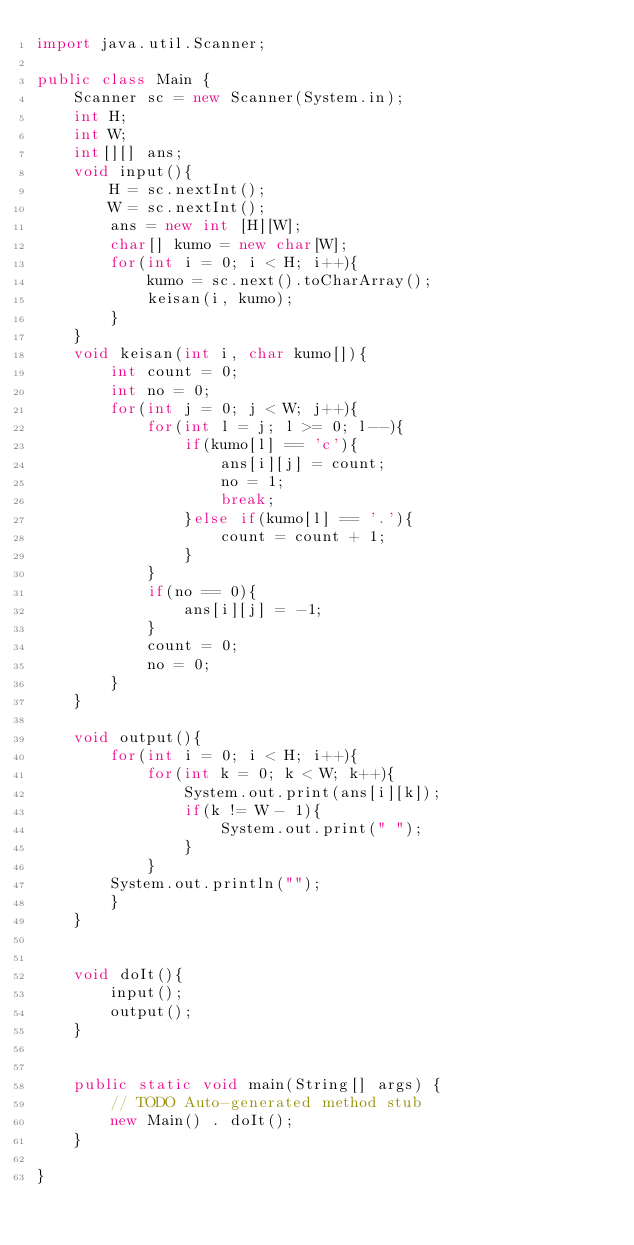<code> <loc_0><loc_0><loc_500><loc_500><_Java_>import java.util.Scanner;

public class Main {
	Scanner sc = new Scanner(System.in);
	int H;
	int W;
	int[][] ans;
	void input(){
		H = sc.nextInt();
		W = sc.nextInt();
		ans = new int [H][W];
		char[] kumo = new char[W];
		for(int i = 0; i < H; i++){
			kumo = sc.next().toCharArray();
			keisan(i, kumo);
		}
	}
	void keisan(int i, char kumo[]){
		int count = 0;
		int no = 0;
		for(int j = 0; j < W; j++){
			for(int l = j; l >= 0; l--){
				if(kumo[l] == 'c'){
					ans[i][j] = count;
					no = 1;
					break;
				}else if(kumo[l] == '.'){
					count = count + 1;
				}
			}
			if(no == 0){
				ans[i][j] = -1;
			}
			count = 0;
			no = 0;
		}
	}
	
	void output(){
		for(int i = 0; i < H; i++){
			for(int k = 0; k < W; k++){
				System.out.print(ans[i][k]);
				if(k != W - 1){
					System.out.print(" ");
				}
			}
		System.out.println("");
		}
	}
	
	
	void doIt(){
		input();
		output();
	}
	

	public static void main(String[] args) {
		// TODO Auto-generated method stub
		new Main() . doIt();
	}

}</code> 